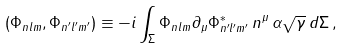<formula> <loc_0><loc_0><loc_500><loc_500>( \Phi _ { n l m } , \Phi _ { n ^ { \prime } l ^ { \prime } m ^ { \prime } } ) \equiv - i \int _ { \Sigma } \Phi _ { n l m } \partial _ { \mu } \Phi ^ { * } _ { n ^ { \prime } l ^ { \prime } m ^ { \prime } } \, n ^ { \mu } \, \alpha \sqrt { \gamma } \, d \Sigma \, ,</formula> 